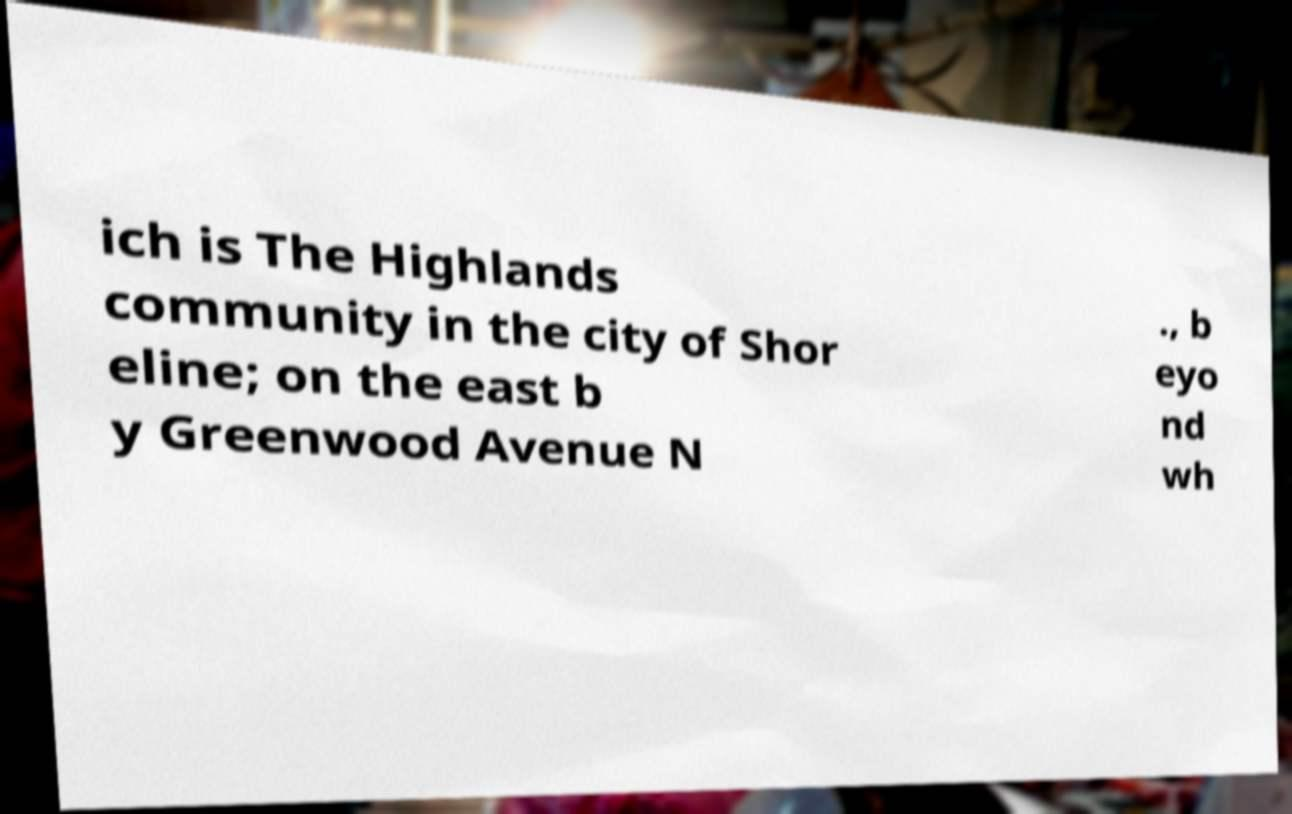Please identify and transcribe the text found in this image. ich is The Highlands community in the city of Shor eline; on the east b y Greenwood Avenue N ., b eyo nd wh 